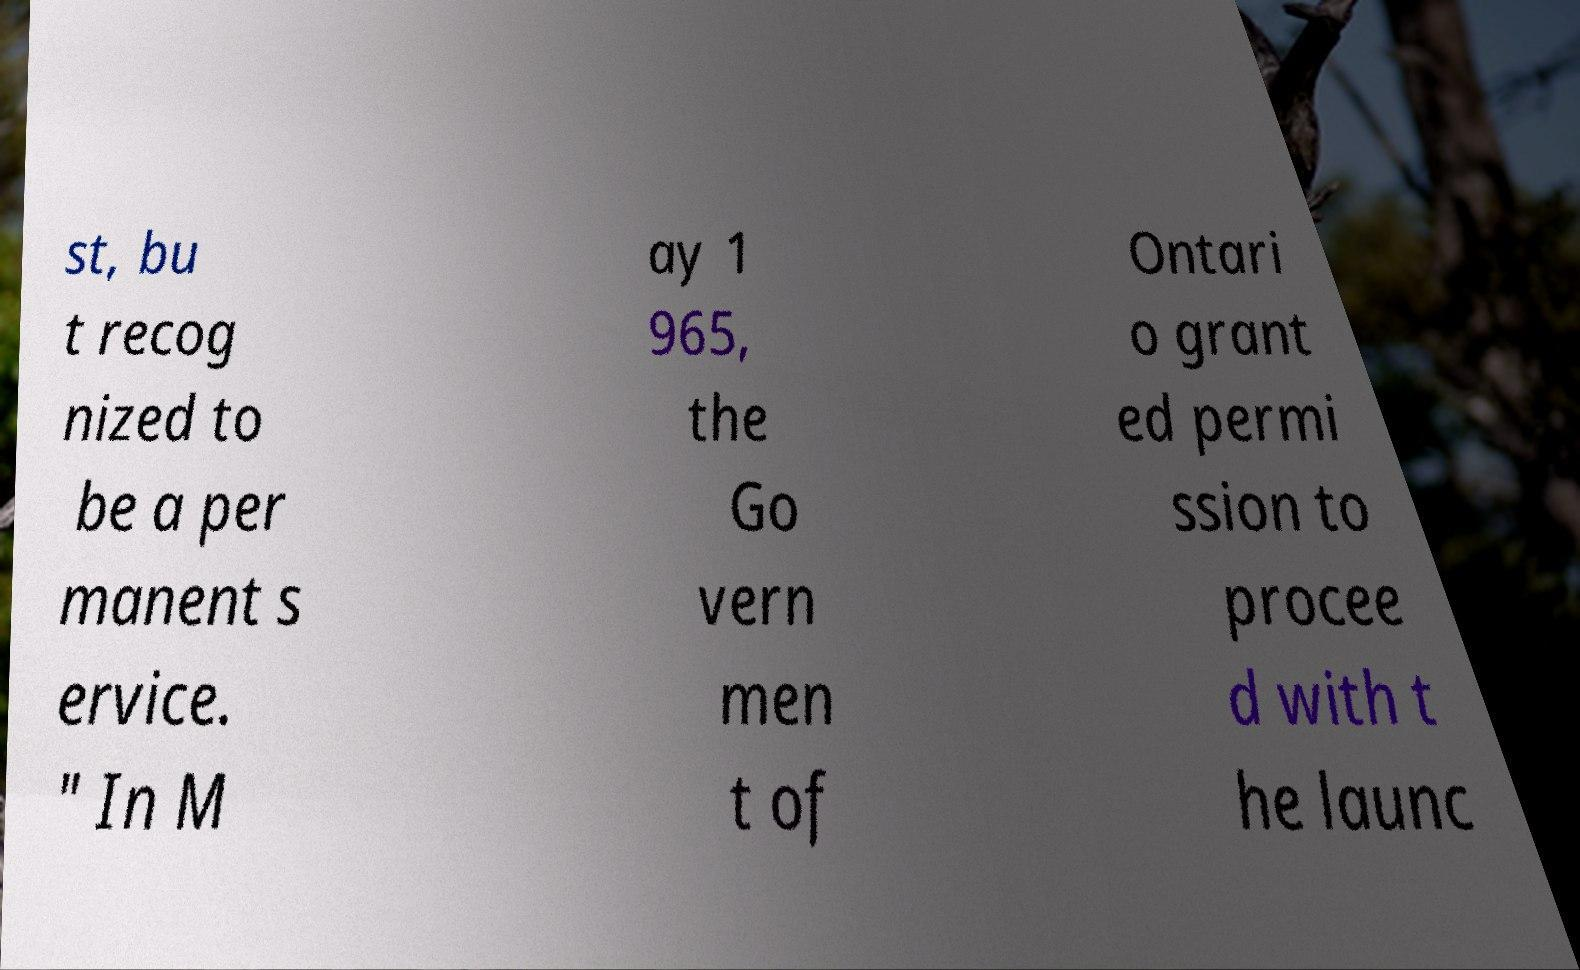Could you extract and type out the text from this image? st, bu t recog nized to be a per manent s ervice. " In M ay 1 965, the Go vern men t of Ontari o grant ed permi ssion to procee d with t he launc 